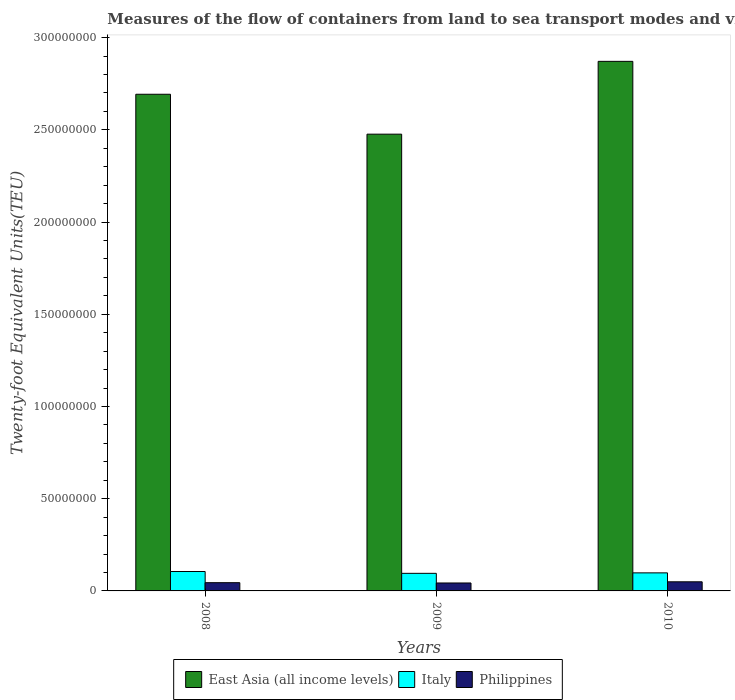How many different coloured bars are there?
Make the answer very short. 3. Are the number of bars on each tick of the X-axis equal?
Your answer should be very brief. Yes. What is the label of the 3rd group of bars from the left?
Your answer should be compact. 2010. In how many cases, is the number of bars for a given year not equal to the number of legend labels?
Offer a terse response. 0. What is the container port traffic in Philippines in 2010?
Keep it short and to the point. 4.95e+06. Across all years, what is the maximum container port traffic in East Asia (all income levels)?
Your answer should be very brief. 2.87e+08. Across all years, what is the minimum container port traffic in Italy?
Your response must be concise. 9.53e+06. In which year was the container port traffic in Italy minimum?
Make the answer very short. 2009. What is the total container port traffic in Philippines in the graph?
Provide a short and direct response. 1.37e+07. What is the difference between the container port traffic in East Asia (all income levels) in 2008 and that in 2010?
Your response must be concise. -1.78e+07. What is the difference between the container port traffic in East Asia (all income levels) in 2008 and the container port traffic in Philippines in 2010?
Offer a terse response. 2.64e+08. What is the average container port traffic in East Asia (all income levels) per year?
Your answer should be very brief. 2.68e+08. In the year 2010, what is the difference between the container port traffic in Italy and container port traffic in East Asia (all income levels)?
Your answer should be compact. -2.77e+08. In how many years, is the container port traffic in Italy greater than 290000000 TEU?
Ensure brevity in your answer.  0. What is the ratio of the container port traffic in Italy in 2009 to that in 2010?
Provide a short and direct response. 0.97. Is the difference between the container port traffic in Italy in 2009 and 2010 greater than the difference between the container port traffic in East Asia (all income levels) in 2009 and 2010?
Offer a terse response. Yes. What is the difference between the highest and the second highest container port traffic in Philippines?
Ensure brevity in your answer.  4.76e+05. What is the difference between the highest and the lowest container port traffic in East Asia (all income levels)?
Provide a succinct answer. 3.95e+07. Is the sum of the container port traffic in East Asia (all income levels) in 2008 and 2009 greater than the maximum container port traffic in Philippines across all years?
Ensure brevity in your answer.  Yes. What does the 1st bar from the left in 2009 represents?
Keep it short and to the point. East Asia (all income levels). Is it the case that in every year, the sum of the container port traffic in Italy and container port traffic in Philippines is greater than the container port traffic in East Asia (all income levels)?
Offer a terse response. No. Are all the bars in the graph horizontal?
Your answer should be compact. No. What is the difference between two consecutive major ticks on the Y-axis?
Make the answer very short. 5.00e+07. Are the values on the major ticks of Y-axis written in scientific E-notation?
Your response must be concise. No. Where does the legend appear in the graph?
Provide a succinct answer. Bottom center. What is the title of the graph?
Your answer should be compact. Measures of the flow of containers from land to sea transport modes and vice versa. What is the label or title of the X-axis?
Provide a short and direct response. Years. What is the label or title of the Y-axis?
Provide a short and direct response. Twenty-foot Equivalent Units(TEU). What is the Twenty-foot Equivalent Units(TEU) of East Asia (all income levels) in 2008?
Provide a succinct answer. 2.69e+08. What is the Twenty-foot Equivalent Units(TEU) in Italy in 2008?
Provide a succinct answer. 1.05e+07. What is the Twenty-foot Equivalent Units(TEU) in Philippines in 2008?
Your response must be concise. 4.47e+06. What is the Twenty-foot Equivalent Units(TEU) of East Asia (all income levels) in 2009?
Keep it short and to the point. 2.48e+08. What is the Twenty-foot Equivalent Units(TEU) of Italy in 2009?
Your answer should be very brief. 9.53e+06. What is the Twenty-foot Equivalent Units(TEU) of Philippines in 2009?
Your answer should be compact. 4.31e+06. What is the Twenty-foot Equivalent Units(TEU) of East Asia (all income levels) in 2010?
Your response must be concise. 2.87e+08. What is the Twenty-foot Equivalent Units(TEU) in Italy in 2010?
Offer a terse response. 9.79e+06. What is the Twenty-foot Equivalent Units(TEU) of Philippines in 2010?
Give a very brief answer. 4.95e+06. Across all years, what is the maximum Twenty-foot Equivalent Units(TEU) of East Asia (all income levels)?
Provide a short and direct response. 2.87e+08. Across all years, what is the maximum Twenty-foot Equivalent Units(TEU) in Italy?
Offer a very short reply. 1.05e+07. Across all years, what is the maximum Twenty-foot Equivalent Units(TEU) of Philippines?
Keep it short and to the point. 4.95e+06. Across all years, what is the minimum Twenty-foot Equivalent Units(TEU) of East Asia (all income levels)?
Your answer should be compact. 2.48e+08. Across all years, what is the minimum Twenty-foot Equivalent Units(TEU) of Italy?
Your response must be concise. 9.53e+06. Across all years, what is the minimum Twenty-foot Equivalent Units(TEU) of Philippines?
Give a very brief answer. 4.31e+06. What is the total Twenty-foot Equivalent Units(TEU) in East Asia (all income levels) in the graph?
Ensure brevity in your answer.  8.04e+08. What is the total Twenty-foot Equivalent Units(TEU) in Italy in the graph?
Your answer should be very brief. 2.99e+07. What is the total Twenty-foot Equivalent Units(TEU) of Philippines in the graph?
Keep it short and to the point. 1.37e+07. What is the difference between the Twenty-foot Equivalent Units(TEU) of East Asia (all income levels) in 2008 and that in 2009?
Ensure brevity in your answer.  2.16e+07. What is the difference between the Twenty-foot Equivalent Units(TEU) in Italy in 2008 and that in 2009?
Make the answer very short. 9.98e+05. What is the difference between the Twenty-foot Equivalent Units(TEU) in Philippines in 2008 and that in 2009?
Ensure brevity in your answer.  1.64e+05. What is the difference between the Twenty-foot Equivalent Units(TEU) in East Asia (all income levels) in 2008 and that in 2010?
Make the answer very short. -1.78e+07. What is the difference between the Twenty-foot Equivalent Units(TEU) of Italy in 2008 and that in 2010?
Ensure brevity in your answer.  7.43e+05. What is the difference between the Twenty-foot Equivalent Units(TEU) of Philippines in 2008 and that in 2010?
Your answer should be very brief. -4.76e+05. What is the difference between the Twenty-foot Equivalent Units(TEU) in East Asia (all income levels) in 2009 and that in 2010?
Make the answer very short. -3.95e+07. What is the difference between the Twenty-foot Equivalent Units(TEU) in Italy in 2009 and that in 2010?
Provide a short and direct response. -2.55e+05. What is the difference between the Twenty-foot Equivalent Units(TEU) of Philippines in 2009 and that in 2010?
Provide a succinct answer. -6.40e+05. What is the difference between the Twenty-foot Equivalent Units(TEU) of East Asia (all income levels) in 2008 and the Twenty-foot Equivalent Units(TEU) of Italy in 2009?
Ensure brevity in your answer.  2.60e+08. What is the difference between the Twenty-foot Equivalent Units(TEU) in East Asia (all income levels) in 2008 and the Twenty-foot Equivalent Units(TEU) in Philippines in 2009?
Your answer should be compact. 2.65e+08. What is the difference between the Twenty-foot Equivalent Units(TEU) of Italy in 2008 and the Twenty-foot Equivalent Units(TEU) of Philippines in 2009?
Your answer should be very brief. 6.22e+06. What is the difference between the Twenty-foot Equivalent Units(TEU) in East Asia (all income levels) in 2008 and the Twenty-foot Equivalent Units(TEU) in Italy in 2010?
Ensure brevity in your answer.  2.60e+08. What is the difference between the Twenty-foot Equivalent Units(TEU) in East Asia (all income levels) in 2008 and the Twenty-foot Equivalent Units(TEU) in Philippines in 2010?
Your answer should be very brief. 2.64e+08. What is the difference between the Twenty-foot Equivalent Units(TEU) in Italy in 2008 and the Twenty-foot Equivalent Units(TEU) in Philippines in 2010?
Offer a very short reply. 5.58e+06. What is the difference between the Twenty-foot Equivalent Units(TEU) of East Asia (all income levels) in 2009 and the Twenty-foot Equivalent Units(TEU) of Italy in 2010?
Give a very brief answer. 2.38e+08. What is the difference between the Twenty-foot Equivalent Units(TEU) of East Asia (all income levels) in 2009 and the Twenty-foot Equivalent Units(TEU) of Philippines in 2010?
Give a very brief answer. 2.43e+08. What is the difference between the Twenty-foot Equivalent Units(TEU) in Italy in 2009 and the Twenty-foot Equivalent Units(TEU) in Philippines in 2010?
Your response must be concise. 4.59e+06. What is the average Twenty-foot Equivalent Units(TEU) in East Asia (all income levels) per year?
Your answer should be very brief. 2.68e+08. What is the average Twenty-foot Equivalent Units(TEU) in Italy per year?
Your answer should be very brief. 9.95e+06. What is the average Twenty-foot Equivalent Units(TEU) in Philippines per year?
Give a very brief answer. 4.58e+06. In the year 2008, what is the difference between the Twenty-foot Equivalent Units(TEU) of East Asia (all income levels) and Twenty-foot Equivalent Units(TEU) of Italy?
Keep it short and to the point. 2.59e+08. In the year 2008, what is the difference between the Twenty-foot Equivalent Units(TEU) in East Asia (all income levels) and Twenty-foot Equivalent Units(TEU) in Philippines?
Give a very brief answer. 2.65e+08. In the year 2008, what is the difference between the Twenty-foot Equivalent Units(TEU) in Italy and Twenty-foot Equivalent Units(TEU) in Philippines?
Offer a very short reply. 6.06e+06. In the year 2009, what is the difference between the Twenty-foot Equivalent Units(TEU) of East Asia (all income levels) and Twenty-foot Equivalent Units(TEU) of Italy?
Your answer should be compact. 2.38e+08. In the year 2009, what is the difference between the Twenty-foot Equivalent Units(TEU) of East Asia (all income levels) and Twenty-foot Equivalent Units(TEU) of Philippines?
Provide a succinct answer. 2.43e+08. In the year 2009, what is the difference between the Twenty-foot Equivalent Units(TEU) in Italy and Twenty-foot Equivalent Units(TEU) in Philippines?
Offer a terse response. 5.23e+06. In the year 2010, what is the difference between the Twenty-foot Equivalent Units(TEU) in East Asia (all income levels) and Twenty-foot Equivalent Units(TEU) in Italy?
Your response must be concise. 2.77e+08. In the year 2010, what is the difference between the Twenty-foot Equivalent Units(TEU) of East Asia (all income levels) and Twenty-foot Equivalent Units(TEU) of Philippines?
Ensure brevity in your answer.  2.82e+08. In the year 2010, what is the difference between the Twenty-foot Equivalent Units(TEU) in Italy and Twenty-foot Equivalent Units(TEU) in Philippines?
Offer a terse response. 4.84e+06. What is the ratio of the Twenty-foot Equivalent Units(TEU) of East Asia (all income levels) in 2008 to that in 2009?
Offer a very short reply. 1.09. What is the ratio of the Twenty-foot Equivalent Units(TEU) in Italy in 2008 to that in 2009?
Your answer should be compact. 1.1. What is the ratio of the Twenty-foot Equivalent Units(TEU) of Philippines in 2008 to that in 2009?
Ensure brevity in your answer.  1.04. What is the ratio of the Twenty-foot Equivalent Units(TEU) of East Asia (all income levels) in 2008 to that in 2010?
Keep it short and to the point. 0.94. What is the ratio of the Twenty-foot Equivalent Units(TEU) in Italy in 2008 to that in 2010?
Your answer should be very brief. 1.08. What is the ratio of the Twenty-foot Equivalent Units(TEU) in Philippines in 2008 to that in 2010?
Offer a terse response. 0.9. What is the ratio of the Twenty-foot Equivalent Units(TEU) in East Asia (all income levels) in 2009 to that in 2010?
Offer a terse response. 0.86. What is the ratio of the Twenty-foot Equivalent Units(TEU) of Italy in 2009 to that in 2010?
Your answer should be compact. 0.97. What is the ratio of the Twenty-foot Equivalent Units(TEU) in Philippines in 2009 to that in 2010?
Offer a very short reply. 0.87. What is the difference between the highest and the second highest Twenty-foot Equivalent Units(TEU) of East Asia (all income levels)?
Provide a succinct answer. 1.78e+07. What is the difference between the highest and the second highest Twenty-foot Equivalent Units(TEU) of Italy?
Ensure brevity in your answer.  7.43e+05. What is the difference between the highest and the second highest Twenty-foot Equivalent Units(TEU) of Philippines?
Provide a succinct answer. 4.76e+05. What is the difference between the highest and the lowest Twenty-foot Equivalent Units(TEU) of East Asia (all income levels)?
Ensure brevity in your answer.  3.95e+07. What is the difference between the highest and the lowest Twenty-foot Equivalent Units(TEU) of Italy?
Your response must be concise. 9.98e+05. What is the difference between the highest and the lowest Twenty-foot Equivalent Units(TEU) in Philippines?
Offer a terse response. 6.40e+05. 